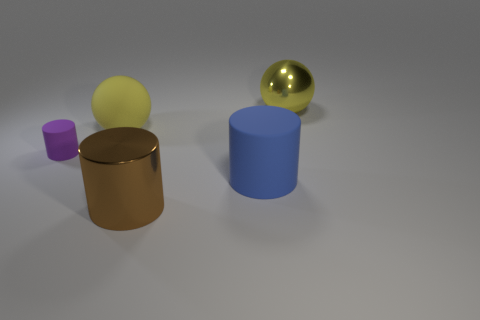Add 5 big blue matte objects. How many objects exist? 10 Subtract all balls. How many objects are left? 3 Subtract 0 blue cubes. How many objects are left? 5 Subtract all rubber balls. Subtract all big yellow objects. How many objects are left? 2 Add 3 spheres. How many spheres are left? 5 Add 1 big yellow shiny cylinders. How many big yellow shiny cylinders exist? 1 